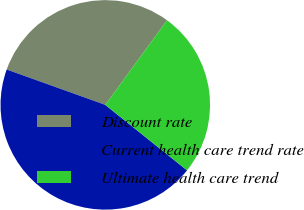<chart> <loc_0><loc_0><loc_500><loc_500><pie_chart><fcel>Discount rate<fcel>Current health care trend rate<fcel>Ultimate health care trend<nl><fcel>29.56%<fcel>44.73%<fcel>25.71%<nl></chart> 